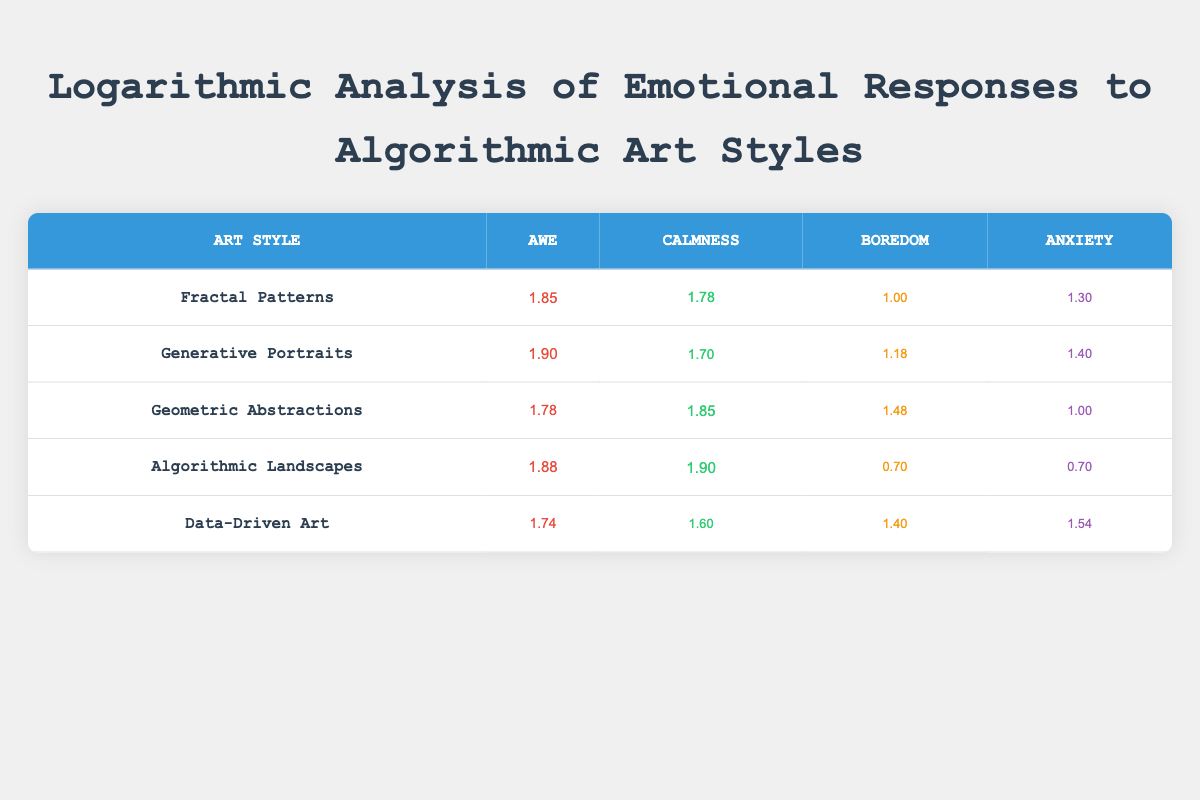What is the emotional response with the highest frequency for Generative Portraits? The table indicates that the emotional response with the highest frequency for Generative Portraits is "awe," which has a value of 80.
Answer: Awe Which art style has the lowest level of boredom? Reviewing the boredom values, Algorithmic Landscapes has the lowest value of 5, indicating the least boredom among the represented styles.
Answer: Algorithmic Landscapes What is the difference in anxiety levels between Fractal Patterns and Geometric Abstractions? The anxiety level for Fractal Patterns is 20, while for Geometric Abstractions, it is 10. The difference is calculated by subtracting the lower value from the higher value: 20 - 10 = 10.
Answer: 10 Are the levels of calmness higher for Algorithmic Landscapes compared to Data-Driven Art? The calmness level for Algorithmic Landscapes is 80, while for Data-Driven Art, it is 40. Since 80 is greater than 40, the statement is true.
Answer: Yes What is the average awe score for all the art styles listed in the table? To find the average awe score, we add the awe scores: 70 + 80 + 60 + 75 + 55 = 340. Then, we divide by the number of art styles (5): 340 / 5 = 68.
Answer: 68 Which emotional response has the same value in Algorithmic Landscapes and Geometric Abstractions? The anxiety levels for both Algorithmic Landscapes and Geometric Abstractions are both 10. This indicates that they share the same level of anxiety.
Answer: 10 What is the highest calmness value among the art styles? The table shows that Algorithmic Landscapes has the highest calmness value at 80, making it the clear leader in that emotional response category.
Answer: 80 Is there an art style that has a boredom level equal to or lower than 15? Upon checking the boredom levels, only Algorithmic Landscapes has a boredom level of 5, which is below 15, confirming that at least one style satisfies this condition.
Answer: Yes 